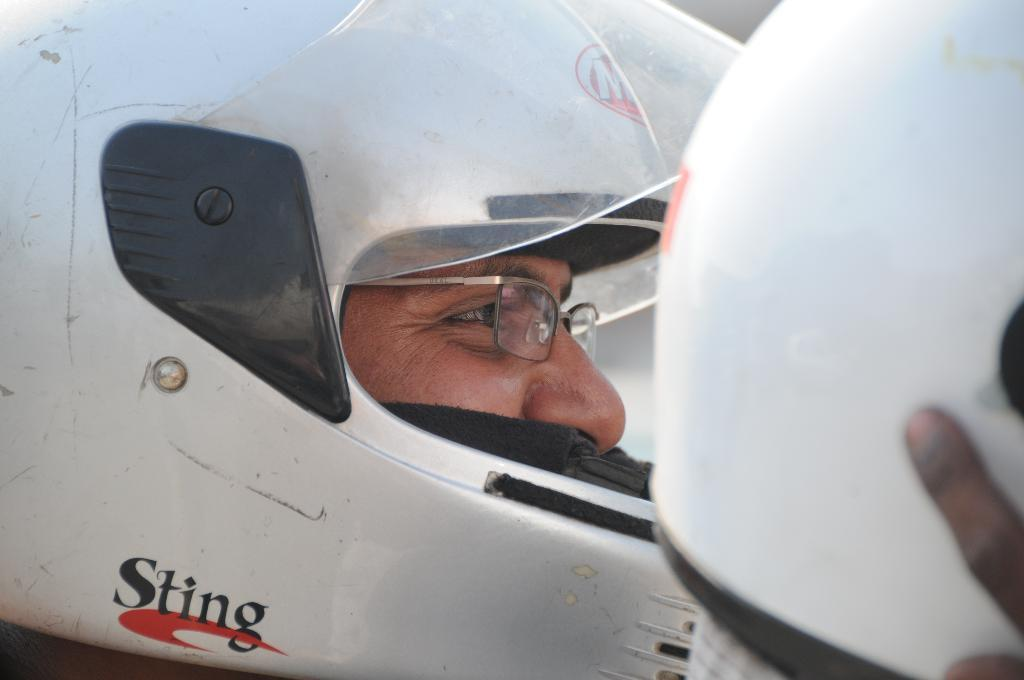Who or what is the main subject of the image? There is a person in the image. What can be seen on the person's face? The person's face is visible in the image. What type of protective gear is the person wearing? The person is wearing a helmet. What color is the helmet? The helmet is white in color. How many clocks are hanging on the wall behind the person in the image? There are no clocks visible in the image; the focus is on the person and their helmet. What shape is the helmet in the image? The helmet's shape cannot be determined from the image alone, as it only provides information about the color of the helmet. 